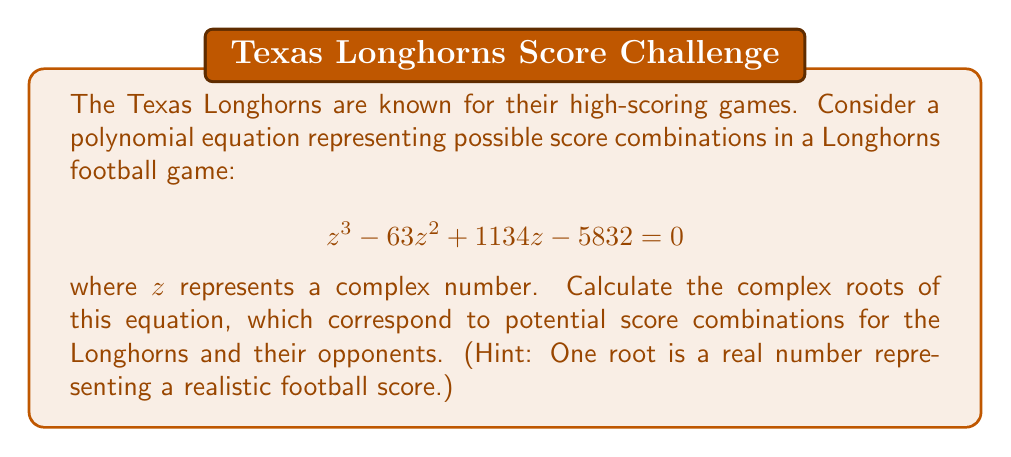Provide a solution to this math problem. Let's approach this step-by-step:

1) First, we can try to find a real root by considering common football scores. Since 36 is a common football score (e.g., 5 touchdowns and 1 field goal), let's try $z = 36$:

   $36^3 - 63(36^2) + 1134(36) - 5832$
   $= 46656 - 81648 + 40824 - 5832 = 0$

   So, 36 is indeed a root.

2) Now that we've found one root, we can factor out $(z - 36)$ from the original polynomial:

   $z^3 - 63z^2 + 1134z - 5832 = (z - 36)(z^2 - 27z + 162)$

3) We're left with a quadratic equation to solve: $z^2 - 27z + 162 = 0$

4) We can solve this using the quadratic formula: $z = \frac{-b \pm \sqrt{b^2 - 4ac}}{2a}$

   Where $a = 1$, $b = -27$, and $c = 162$

5) Plugging in these values:

   $z = \frac{27 \pm \sqrt{(-27)^2 - 4(1)(162)}}{2(1)}$
   $= \frac{27 \pm \sqrt{729 - 648}}{2}$
   $= \frac{27 \pm \sqrt{81}}{2}$
   $= \frac{27 \pm 9}{2}$

6) This gives us two more roots:

   $z = \frac{27 + 9}{2} = 18$ and $z = \frac{27 - 9}{2} = 9$

Therefore, the three roots are 36, 18, and 9.
Answer: The complex roots of the equation are 36, 18, and 9. 